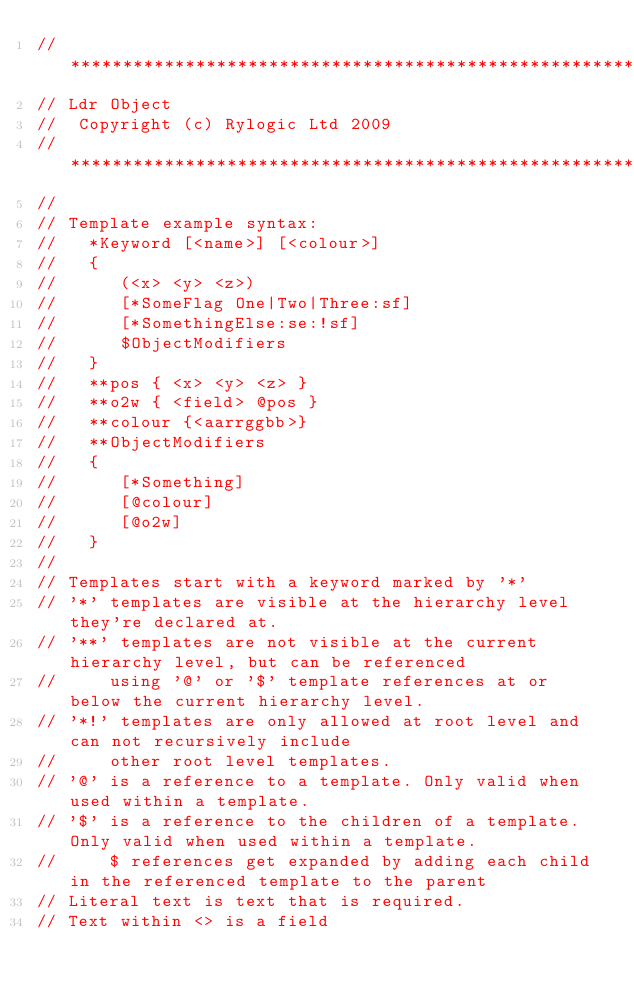Convert code to text. <code><loc_0><loc_0><loc_500><loc_500><_C++_>//***************************************************************************************************
// Ldr Object
//  Copyright (c) Rylogic Ltd 2009
//***************************************************************************************************
//
// Template example syntax:
//   *Keyword [<name>] [<colour>]
//   {
//      (<x> <y> <z>)
//      [*SomeFlag One|Two|Three:sf]
//      [*SomethingElse:se:!sf]
//      $ObjectModifiers
//   }
//   **pos { <x> <y> <z> }
//   **o2w { <field> @pos } 
//   **colour {<aarrggbb>}
//   **ObjectModifiers
//   {
//      [*Something]
//      [@colour]
//      [@o2w]
//   }
// 
// Templates start with a keyword marked by '*'
// '*' templates are visible at the hierarchy level they're declared at.
// '**' templates are not visible at the current hierarchy level, but can be referenced
//     using '@' or '$' template references at or below the current hierarchy level.
// '*!' templates are only allowed at root level and can not recursively include
//     other root level templates.
// '@' is a reference to a template. Only valid when used within a template.
// '$' is a reference to the children of a template. Only valid when used within a template.
//     $ references get expanded by adding each child in the referenced template to the parent
// Literal text is text that is required.
// Text within <> is a field</code> 